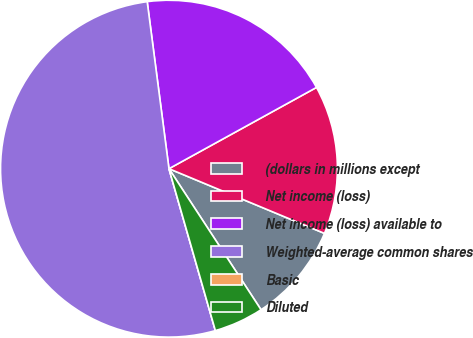<chart> <loc_0><loc_0><loc_500><loc_500><pie_chart><fcel>(dollars in millions except<fcel>Net income (loss)<fcel>Net income (loss) available to<fcel>Weighted-average common shares<fcel>Basic<fcel>Diluted<nl><fcel>9.52%<fcel>14.29%<fcel>19.05%<fcel>52.38%<fcel>0.0%<fcel>4.76%<nl></chart> 